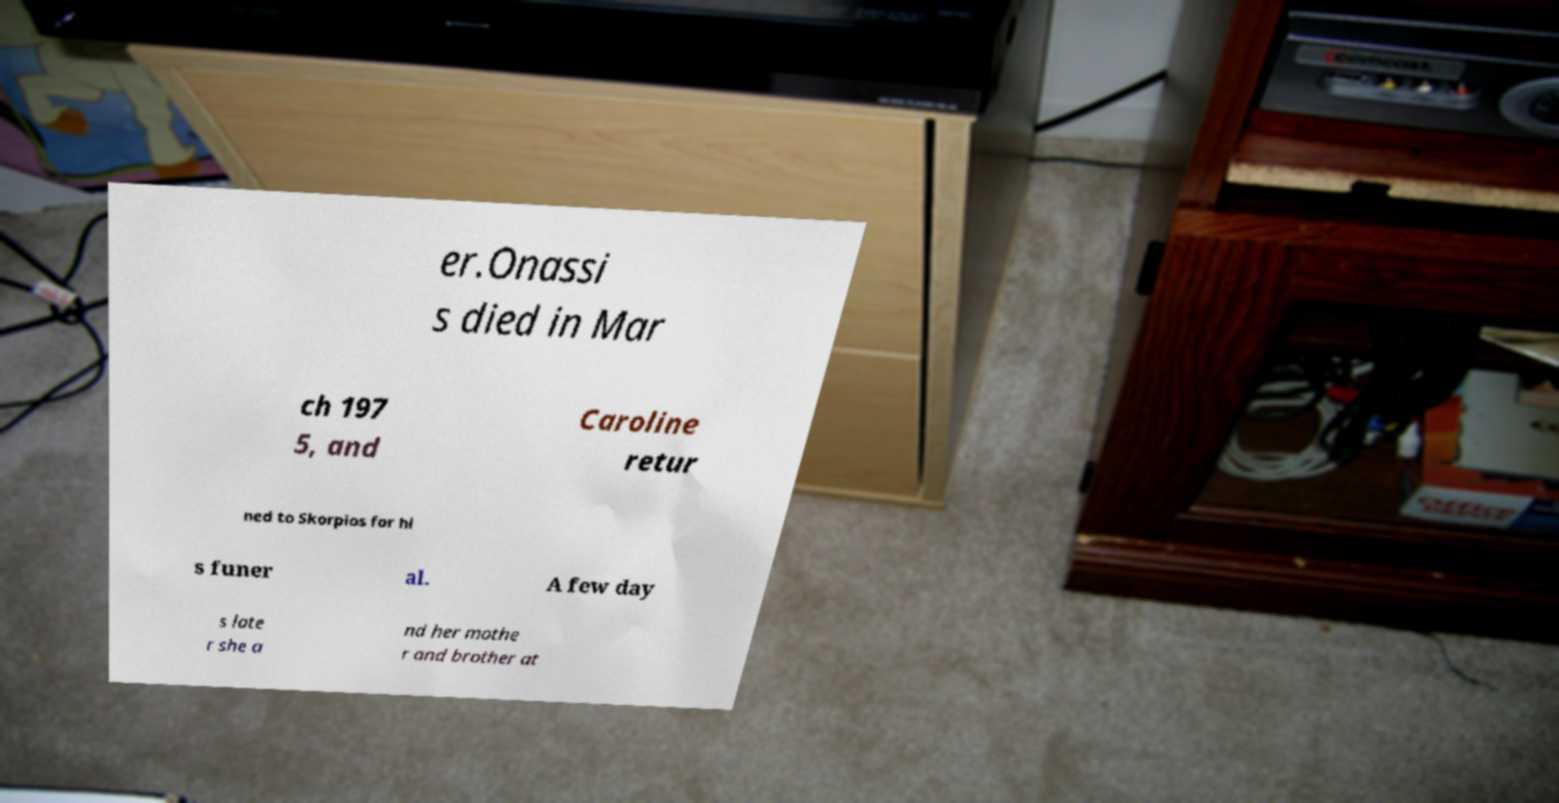Can you read and provide the text displayed in the image?This photo seems to have some interesting text. Can you extract and type it out for me? er.Onassi s died in Mar ch 197 5, and Caroline retur ned to Skorpios for hi s funer al. A few day s late r she a nd her mothe r and brother at 